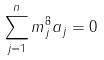<formula> <loc_0><loc_0><loc_500><loc_500>\sum _ { j = 1 } ^ { n } m _ { j } ^ { 8 } a _ { j } = 0</formula> 